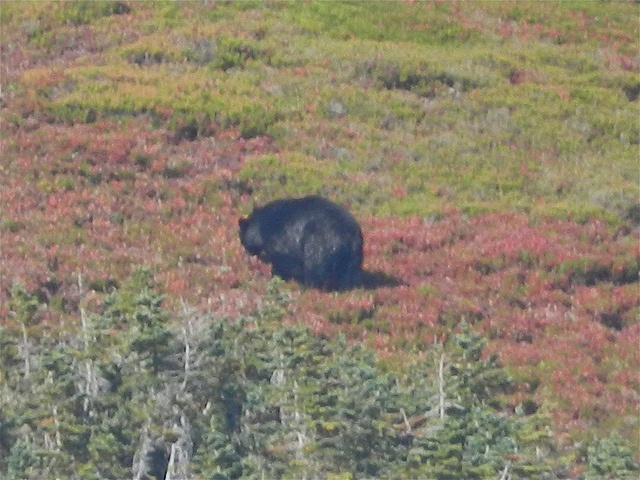Describe the objects in this image and their specific colors. I can see a bear in tan, gray, darkblue, and navy tones in this image. 